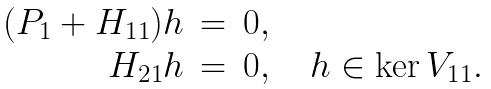<formula> <loc_0><loc_0><loc_500><loc_500>\begin{array} { r c l } ( P _ { 1 } + H _ { 1 1 } ) h & = & 0 , \\ H _ { 2 1 } h & = & 0 , \quad h \in \ker V _ { 1 1 } . \end{array}</formula> 